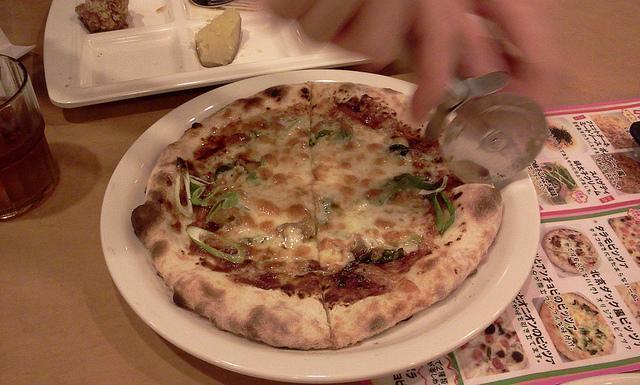In which style white pizza made of?
Select the correct answer and articulate reasoning with the following format: 'Answer: answer
Rationale: rationale.'
Options: German, italian, australian, arab. Answer: italian.
Rationale: A traditional pizza is on a plate. 